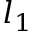<formula> <loc_0><loc_0><loc_500><loc_500>l _ { 1 }</formula> 